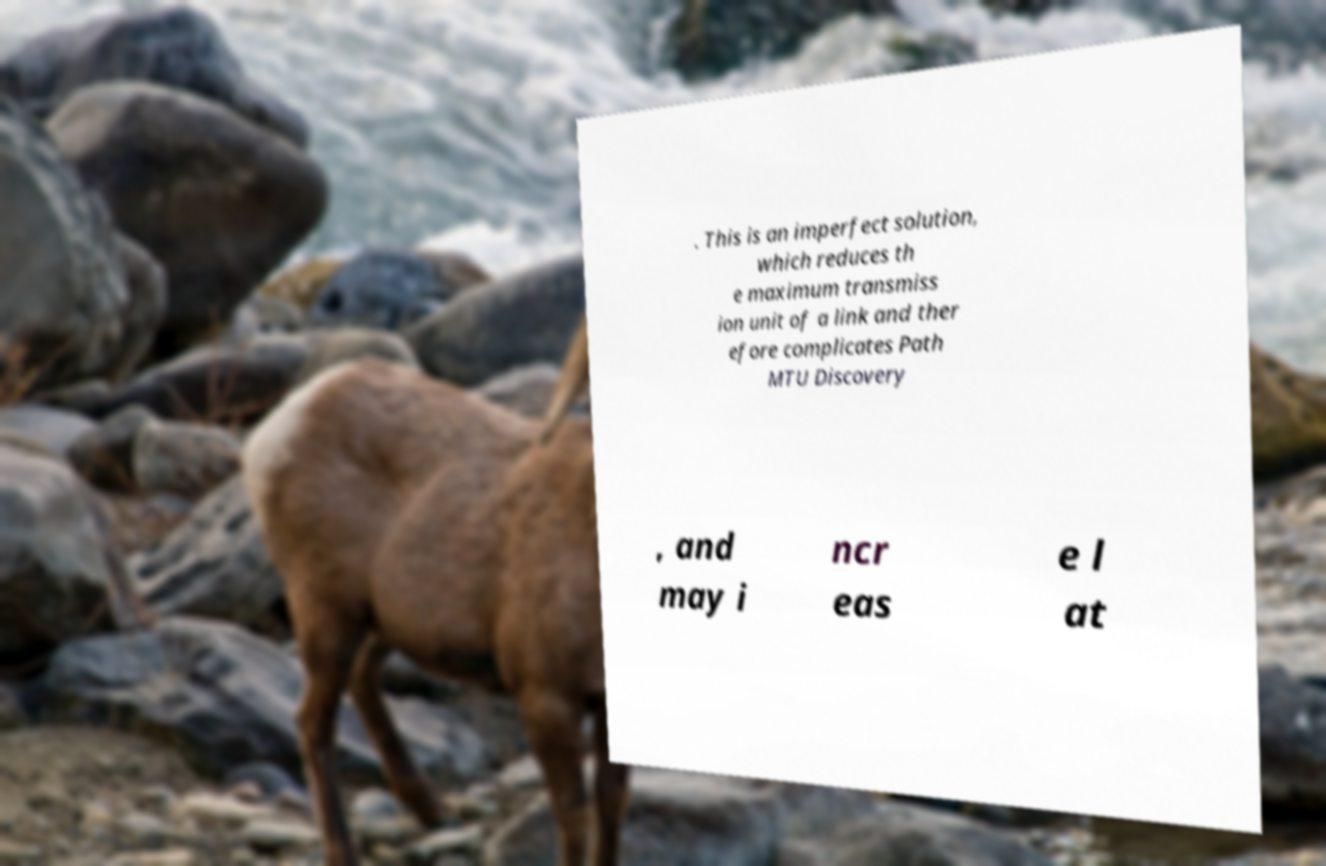Can you read and provide the text displayed in the image?This photo seems to have some interesting text. Can you extract and type it out for me? . This is an imperfect solution, which reduces th e maximum transmiss ion unit of a link and ther efore complicates Path MTU Discovery , and may i ncr eas e l at 